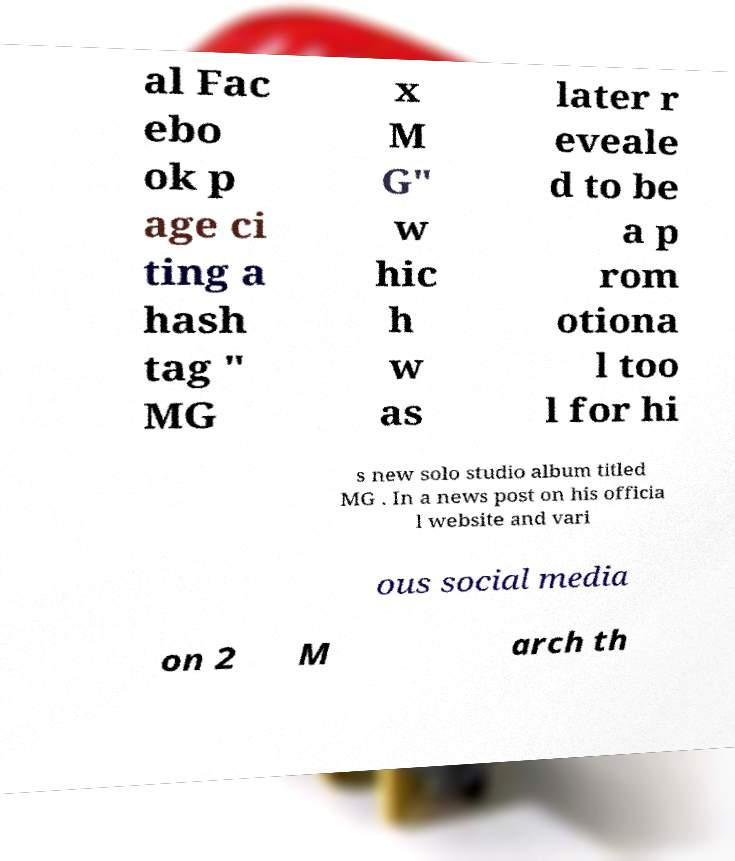I need the written content from this picture converted into text. Can you do that? al Fac ebo ok p age ci ting a hash tag " MG x M G" w hic h w as later r eveale d to be a p rom otiona l too l for hi s new solo studio album titled MG . In a news post on his officia l website and vari ous social media on 2 M arch th 